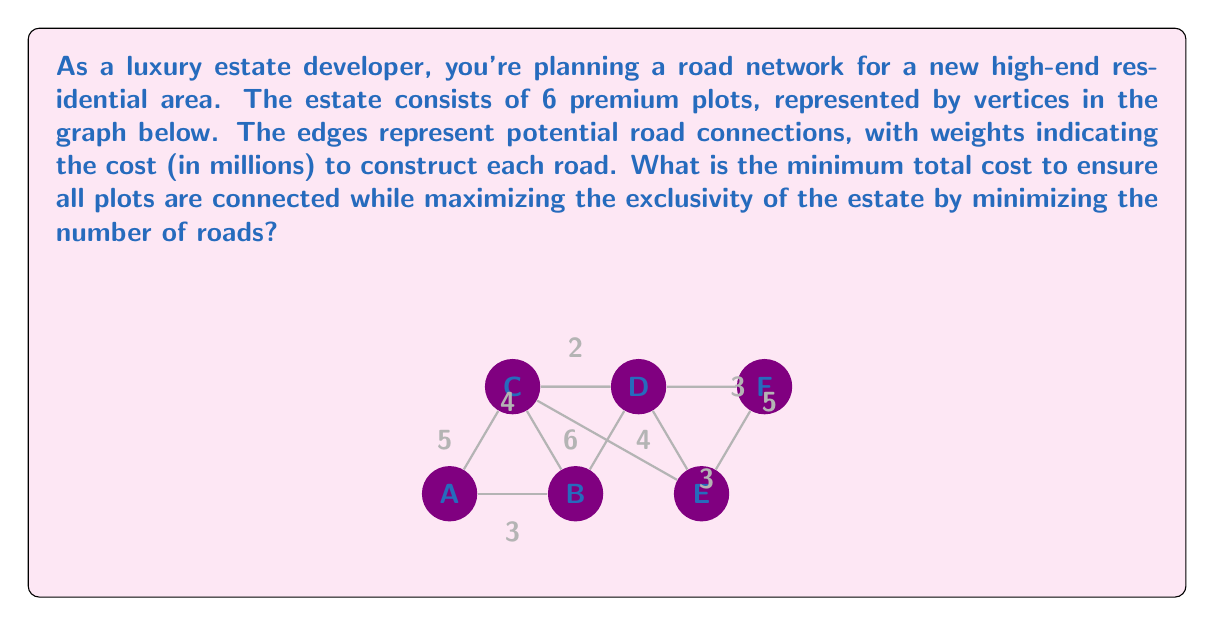Can you answer this question? To solve this problem, we need to find the Minimum Spanning Tree (MST) of the given graph. The MST will connect all vertices (plots) with the minimum total edge weight (road construction cost) while using the fewest number of edges (roads).

We can use Kruskal's algorithm to find the MST:

1. Sort all edges by weight in ascending order:
   C-D (2), A-B (3), D-E (3), D-F (3), B-C (4), C-E (4), A-C (5), E-F (5), B-D (6)

2. Start with an empty set of edges and add edges one by one, skipping those that would create a cycle:

   - Add C-D (2)
   - Add A-B (3)
   - Add D-E (3)
   - Add D-F (3)
   - Skip B-C (4) as it would create a cycle
   - Skip C-E (4) as it would create a cycle
   - Add A-C (5) to complete the MST

3. The resulting MST consists of 5 edges: C-D, A-B, D-E, D-F, and A-C.

4. Calculate the total cost:
   $$\text{Total Cost} = 2 + 3 + 3 + 3 + 5 = 16\text{ million}$$

Therefore, the minimum total cost to connect all plots while maximizing exclusivity is 16 million.
Answer: $16 million 